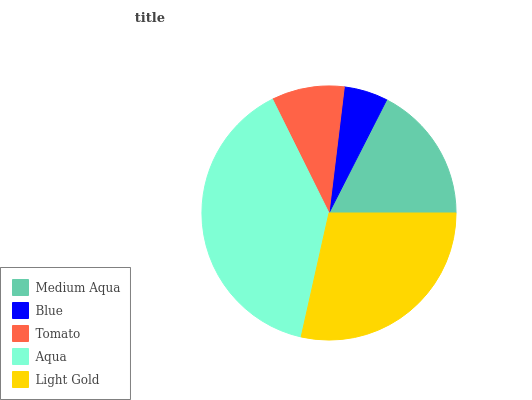Is Blue the minimum?
Answer yes or no. Yes. Is Aqua the maximum?
Answer yes or no. Yes. Is Tomato the minimum?
Answer yes or no. No. Is Tomato the maximum?
Answer yes or no. No. Is Tomato greater than Blue?
Answer yes or no. Yes. Is Blue less than Tomato?
Answer yes or no. Yes. Is Blue greater than Tomato?
Answer yes or no. No. Is Tomato less than Blue?
Answer yes or no. No. Is Medium Aqua the high median?
Answer yes or no. Yes. Is Medium Aqua the low median?
Answer yes or no. Yes. Is Tomato the high median?
Answer yes or no. No. Is Tomato the low median?
Answer yes or no. No. 